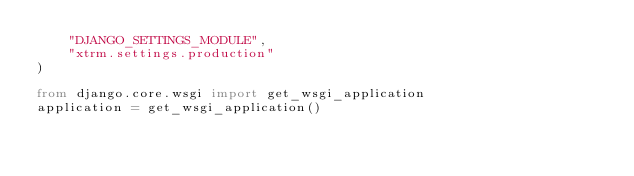Convert code to text. <code><loc_0><loc_0><loc_500><loc_500><_Python_>    "DJANGO_SETTINGS_MODULE",
    "xtrm.settings.production"
)

from django.core.wsgi import get_wsgi_application
application = get_wsgi_application()
</code> 